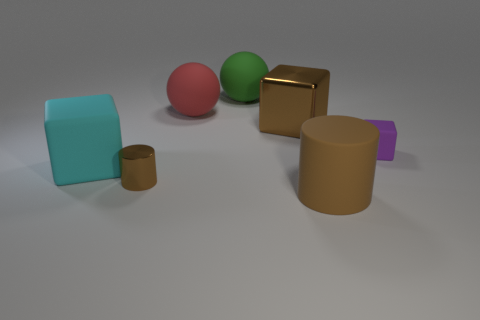Subtract all cyan blocks. How many blocks are left? 2 Subtract all purple blocks. How many blocks are left? 2 Add 1 large cylinders. How many objects exist? 8 Subtract all cubes. How many objects are left? 4 Subtract 2 cylinders. How many cylinders are left? 0 Subtract all brown balls. Subtract all red blocks. How many balls are left? 2 Subtract all big brown metallic blocks. Subtract all big yellow metal things. How many objects are left? 6 Add 2 shiny cylinders. How many shiny cylinders are left? 3 Add 2 large blue spheres. How many large blue spheres exist? 2 Subtract 0 blue cubes. How many objects are left? 7 